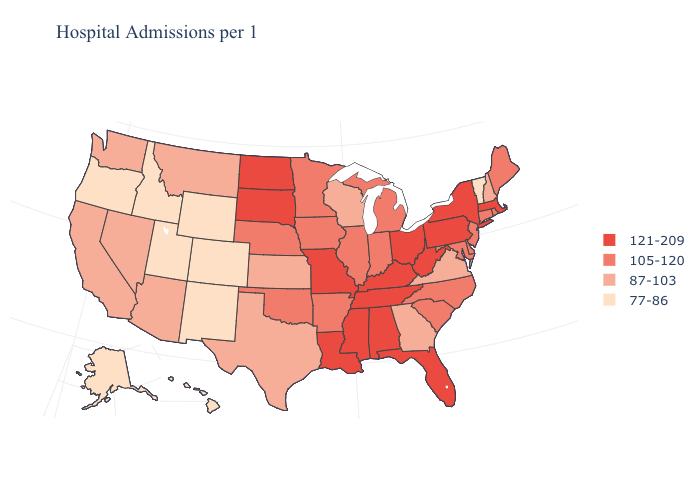What is the highest value in states that border Rhode Island?
Keep it brief. 121-209. What is the value of Michigan?
Give a very brief answer. 105-120. Does New Mexico have a lower value than Vermont?
Keep it brief. No. How many symbols are there in the legend?
Concise answer only. 4. Does Indiana have a lower value than Nebraska?
Concise answer only. No. Which states have the highest value in the USA?
Concise answer only. Alabama, Florida, Kentucky, Louisiana, Massachusetts, Mississippi, Missouri, New York, North Dakota, Ohio, Pennsylvania, South Dakota, Tennessee, West Virginia. Among the states that border Kansas , which have the lowest value?
Keep it brief. Colorado. Name the states that have a value in the range 77-86?
Answer briefly. Alaska, Colorado, Hawaii, Idaho, New Mexico, Oregon, Utah, Vermont, Wyoming. Name the states that have a value in the range 77-86?
Keep it brief. Alaska, Colorado, Hawaii, Idaho, New Mexico, Oregon, Utah, Vermont, Wyoming. Name the states that have a value in the range 121-209?
Quick response, please. Alabama, Florida, Kentucky, Louisiana, Massachusetts, Mississippi, Missouri, New York, North Dakota, Ohio, Pennsylvania, South Dakota, Tennessee, West Virginia. Among the states that border California , which have the highest value?
Be succinct. Arizona, Nevada. What is the lowest value in the MidWest?
Be succinct. 87-103. Name the states that have a value in the range 77-86?
Be succinct. Alaska, Colorado, Hawaii, Idaho, New Mexico, Oregon, Utah, Vermont, Wyoming. Does the map have missing data?
Concise answer only. No. Which states have the lowest value in the USA?
Keep it brief. Alaska, Colorado, Hawaii, Idaho, New Mexico, Oregon, Utah, Vermont, Wyoming. 